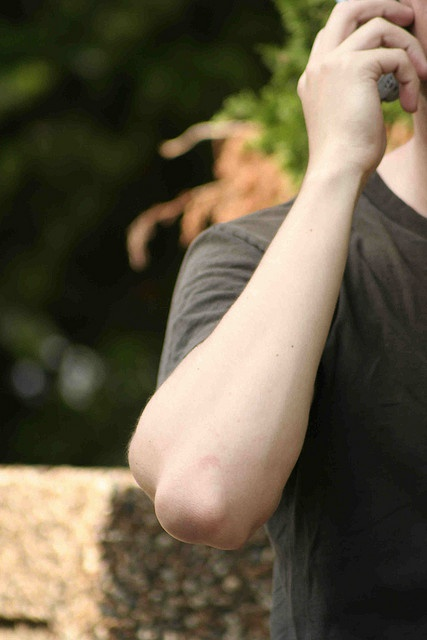Describe the objects in this image and their specific colors. I can see people in black, ivory, gray, and tan tones and cell phone in black and gray tones in this image. 